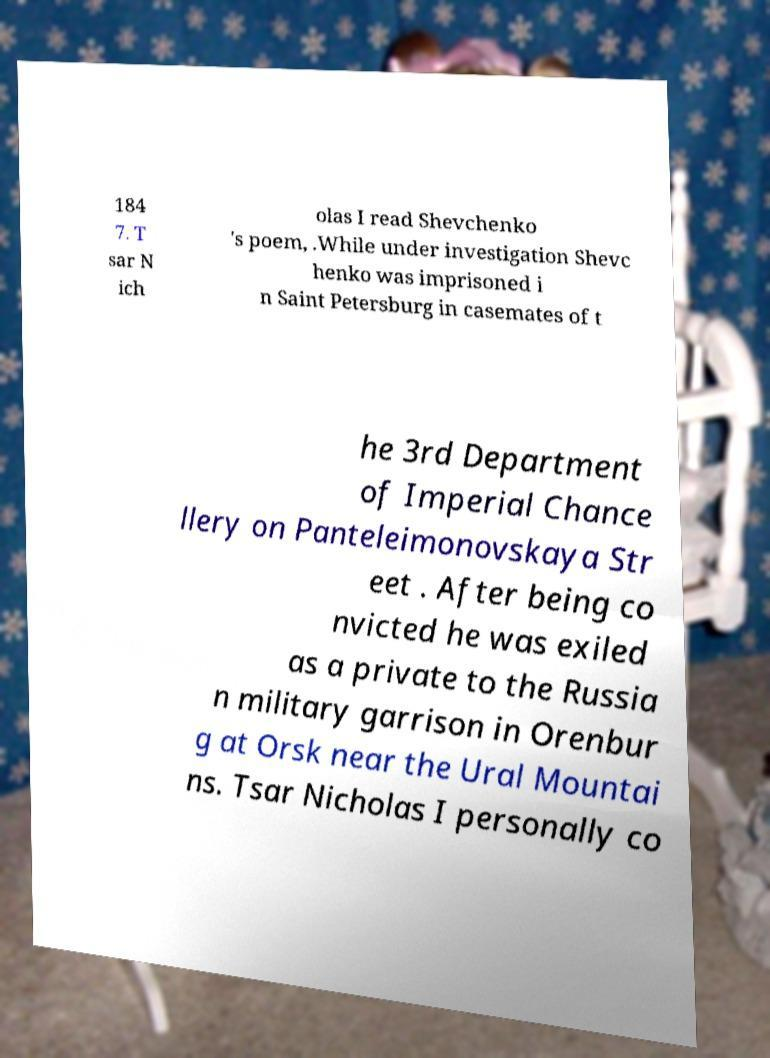Could you extract and type out the text from this image? 184 7. T sar N ich olas I read Shevchenko 's poem, .While under investigation Shevc henko was imprisoned i n Saint Petersburg in casemates of t he 3rd Department of Imperial Chance llery on Panteleimonovskaya Str eet . After being co nvicted he was exiled as a private to the Russia n military garrison in Orenbur g at Orsk near the Ural Mountai ns. Tsar Nicholas I personally co 